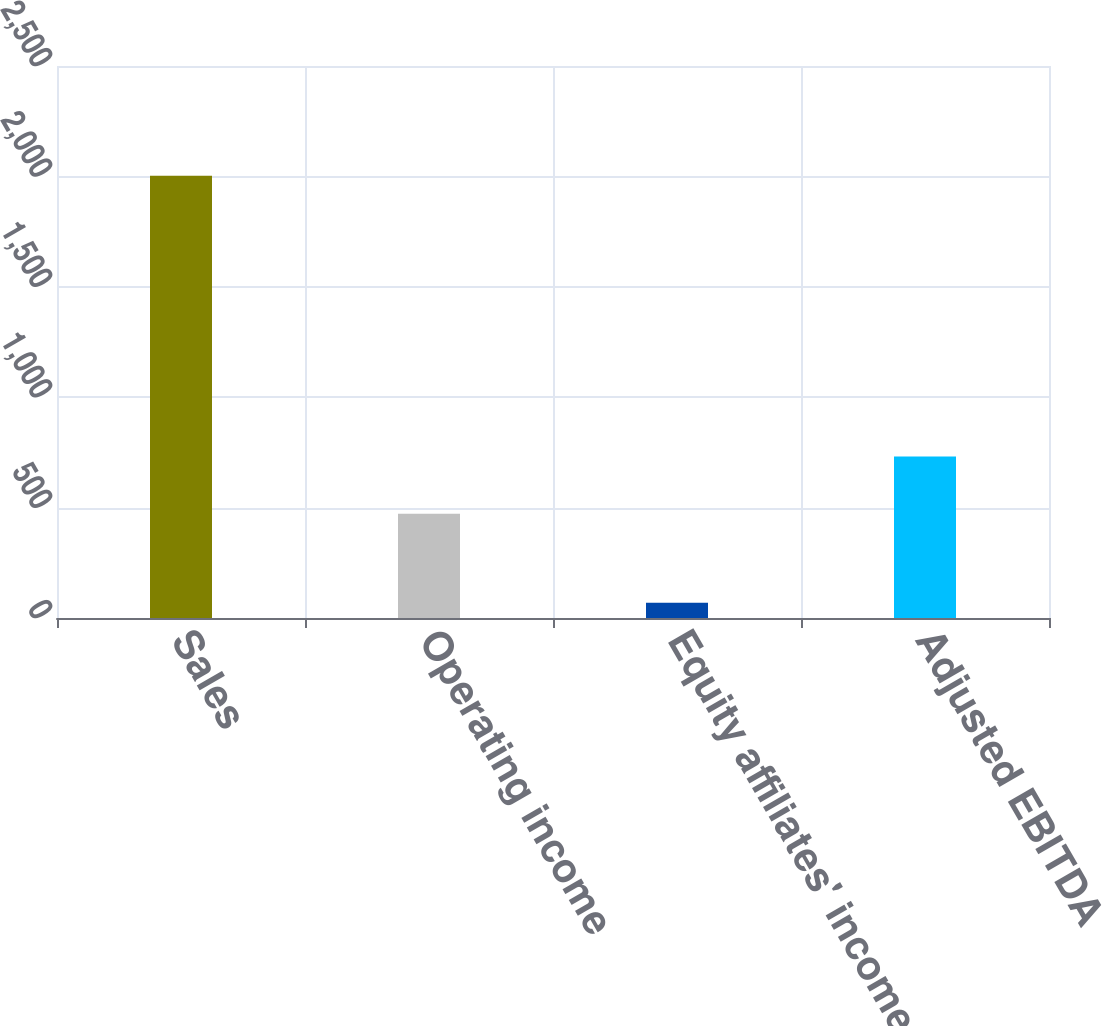Convert chart. <chart><loc_0><loc_0><loc_500><loc_500><bar_chart><fcel>Sales<fcel>Operating income<fcel>Equity affiliates' income<fcel>Adjusted EBITDA<nl><fcel>2002.5<fcel>472.4<fcel>69<fcel>730.9<nl></chart> 